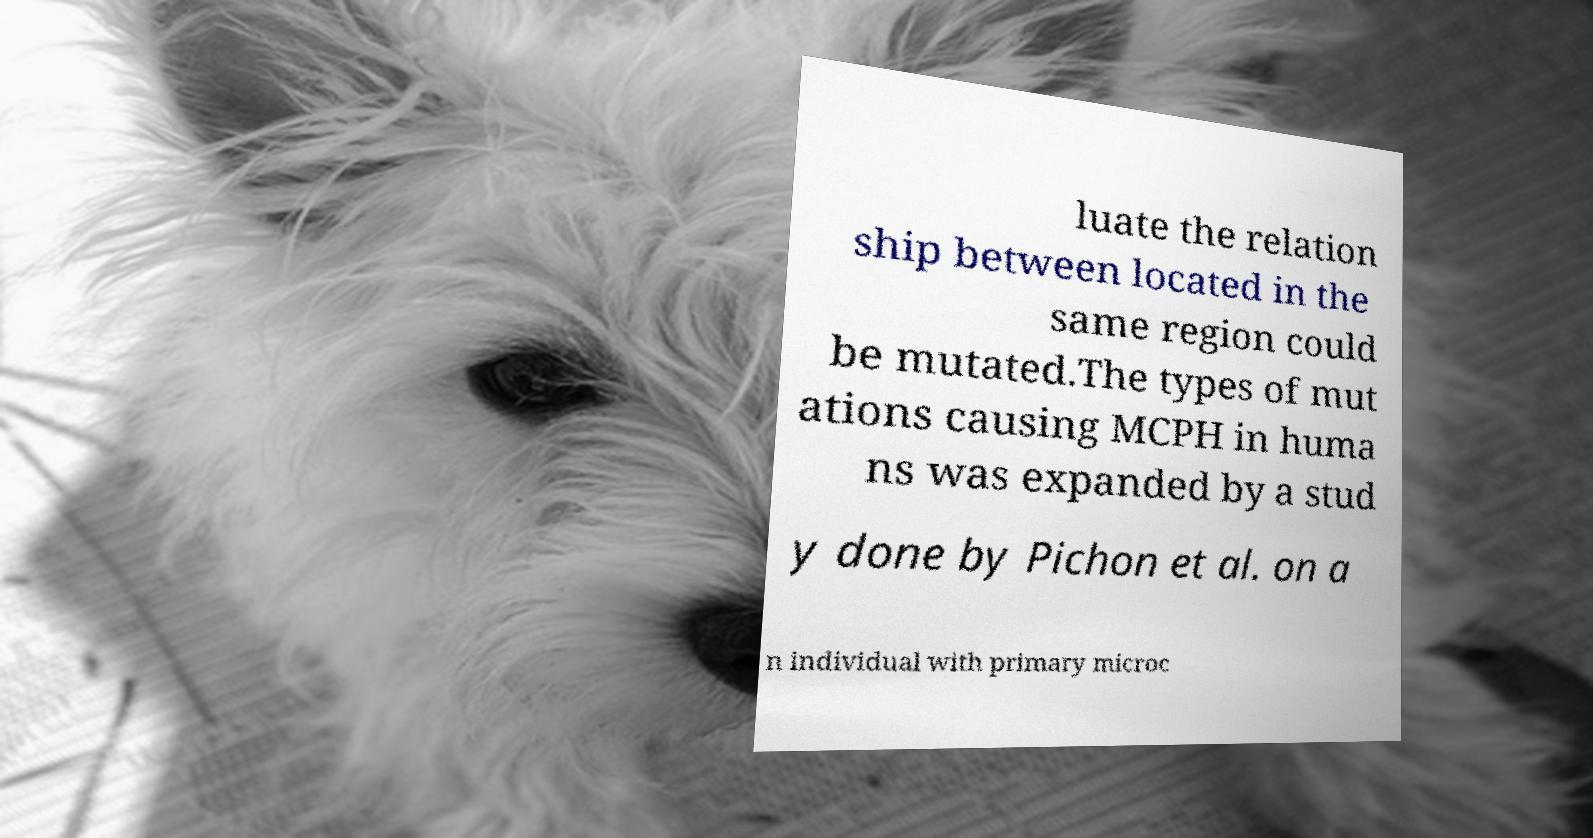What messages or text are displayed in this image? I need them in a readable, typed format. luate the relation ship between located in the same region could be mutated.The types of mut ations causing MCPH in huma ns was expanded by a stud y done by Pichon et al. on a n individual with primary microc 